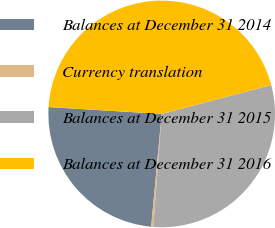Convert chart. <chart><loc_0><loc_0><loc_500><loc_500><pie_chart><fcel>Balances at December 31 2014<fcel>Currency translation<fcel>Balances at December 31 2015<fcel>Balances at December 31 2016<nl><fcel>24.48%<fcel>0.32%<fcel>30.27%<fcel>44.93%<nl></chart> 